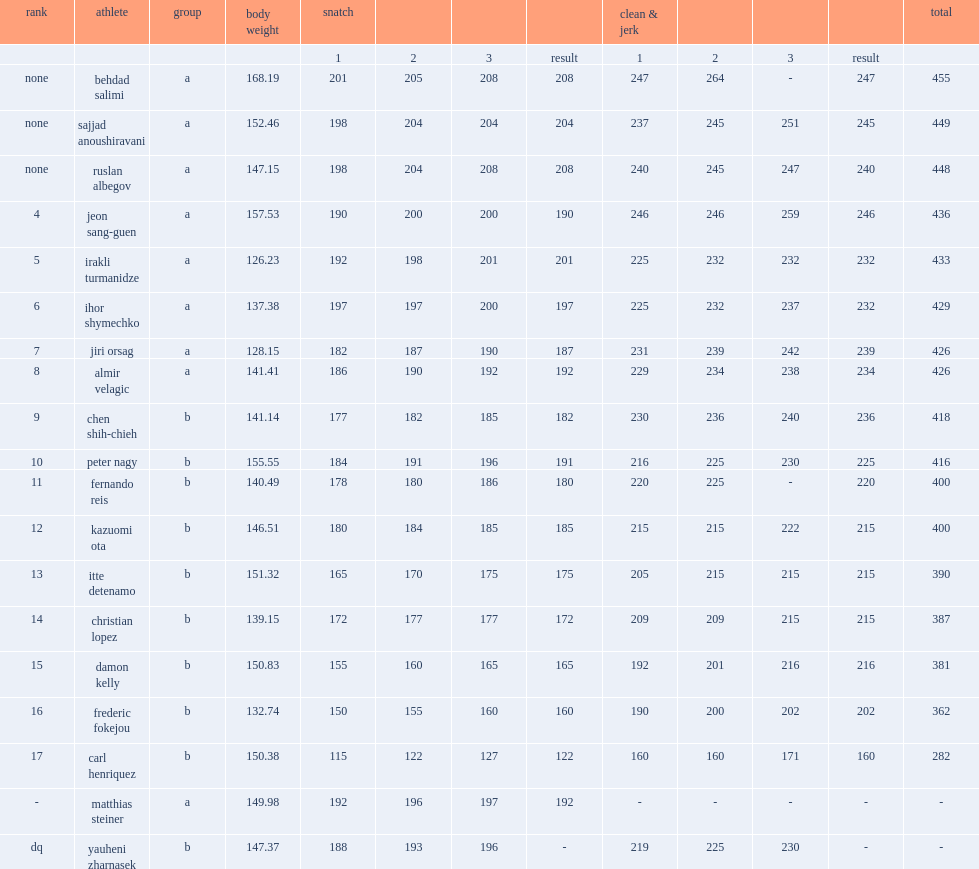What was matthias steiner's second result in snatch (kg)? 196.0. 